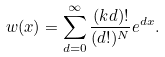Convert formula to latex. <formula><loc_0><loc_0><loc_500><loc_500>w ( x ) = \sum _ { d = 0 } ^ { \infty } \frac { ( k d ) ! } { ( d ! ) ^ { N } } e ^ { d x } .</formula> 